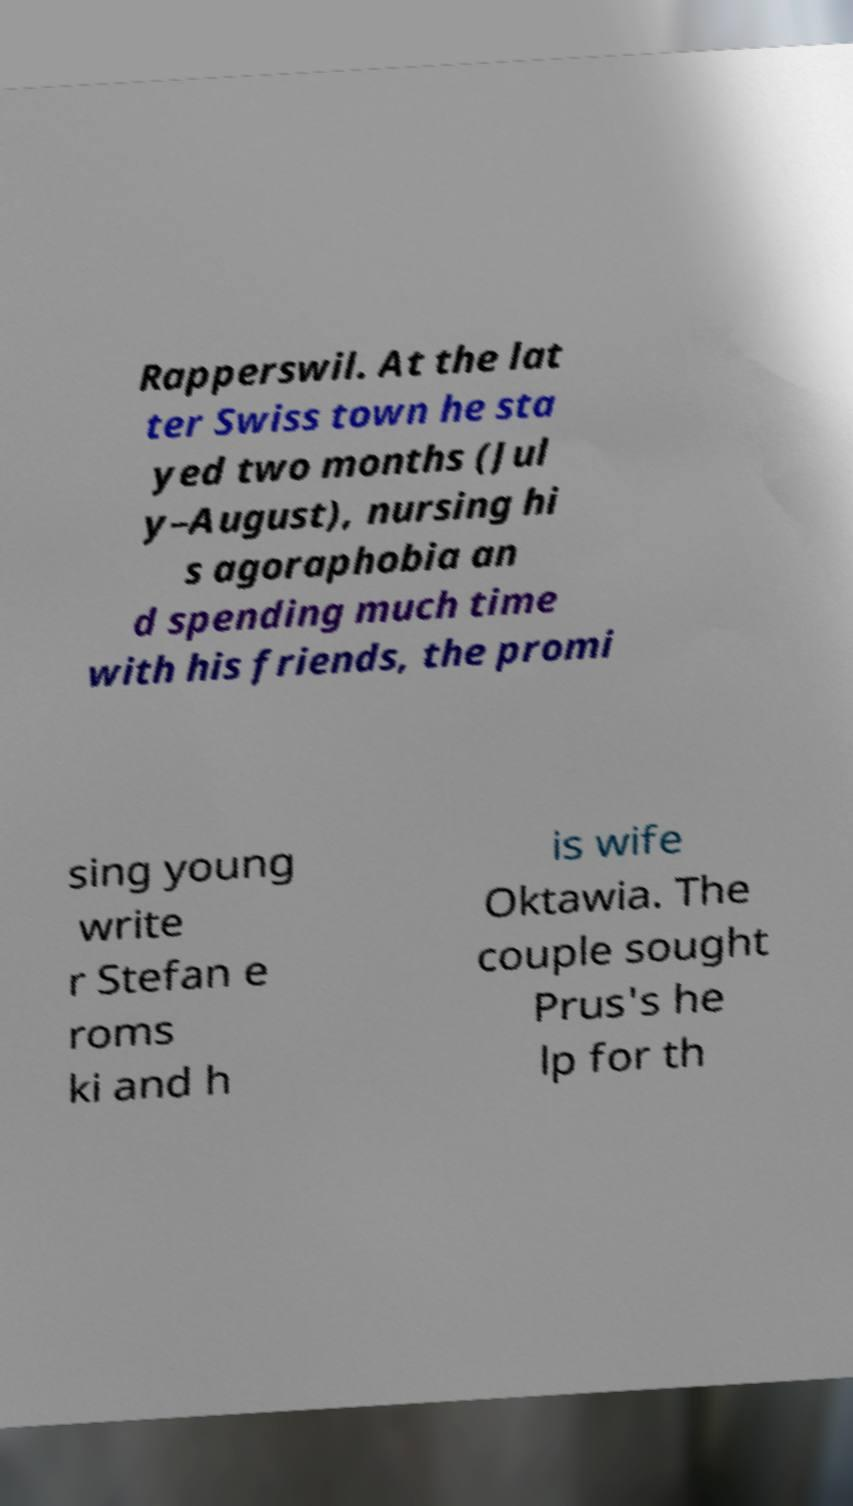There's text embedded in this image that I need extracted. Can you transcribe it verbatim? Rapperswil. At the lat ter Swiss town he sta yed two months (Jul y–August), nursing hi s agoraphobia an d spending much time with his friends, the promi sing young write r Stefan e roms ki and h is wife Oktawia. The couple sought Prus's he lp for th 